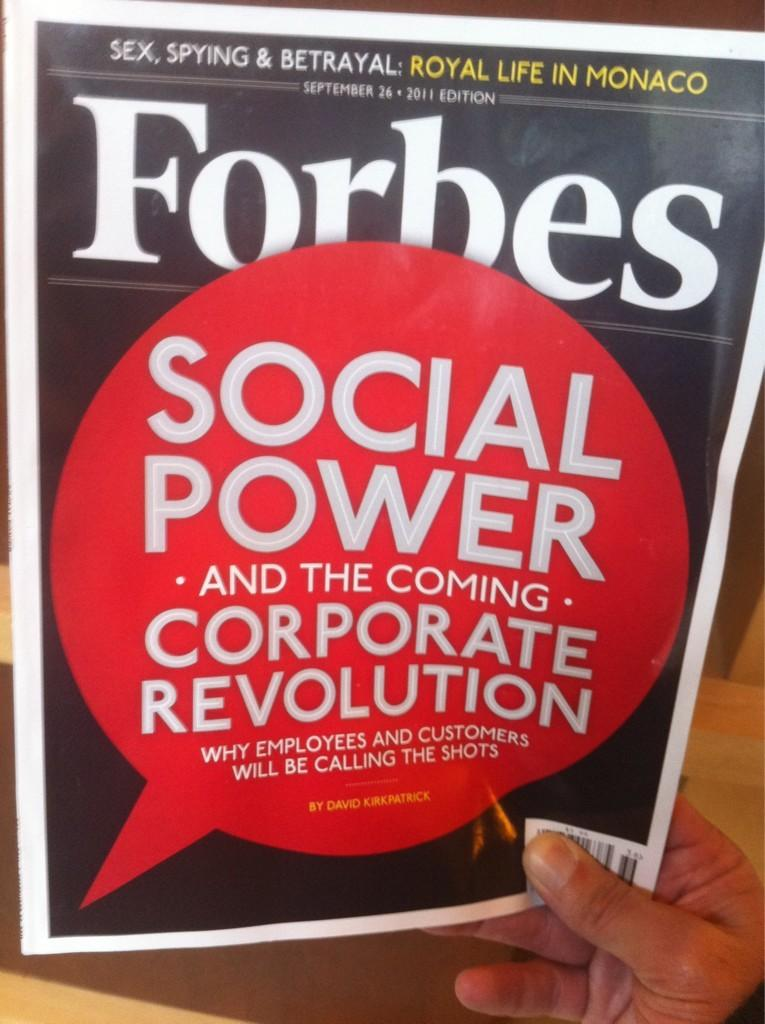<image>
Render a clear and concise summary of the photo. A cover of Forbes magazine shows that there is a story about social power in this issue. 